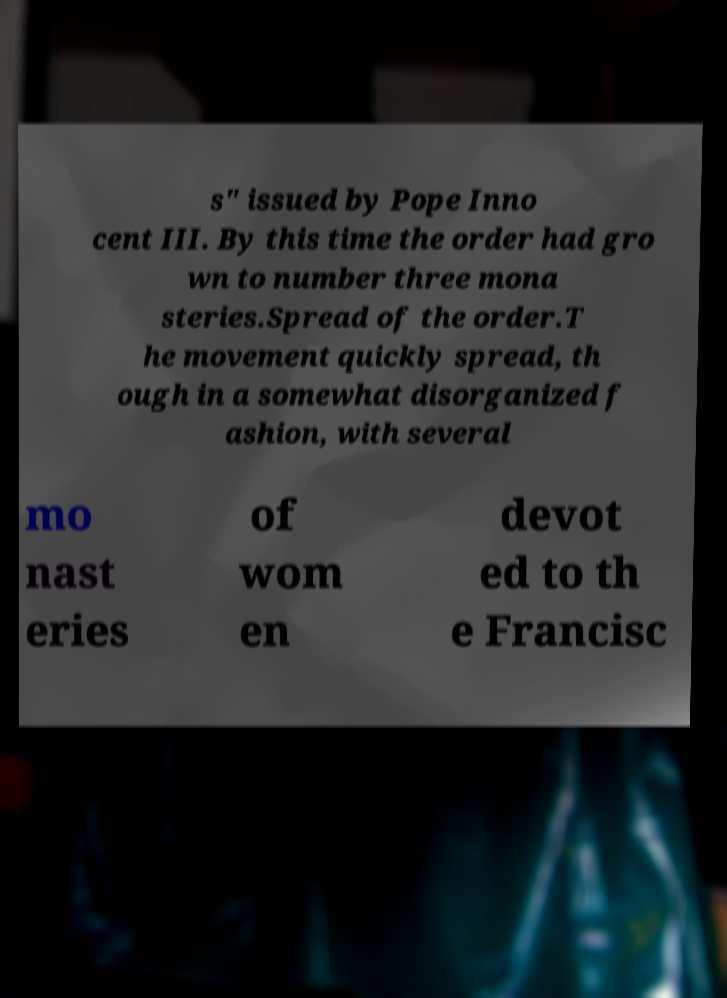There's text embedded in this image that I need extracted. Can you transcribe it verbatim? s" issued by Pope Inno cent III. By this time the order had gro wn to number three mona steries.Spread of the order.T he movement quickly spread, th ough in a somewhat disorganized f ashion, with several mo nast eries of wom en devot ed to th e Francisc 